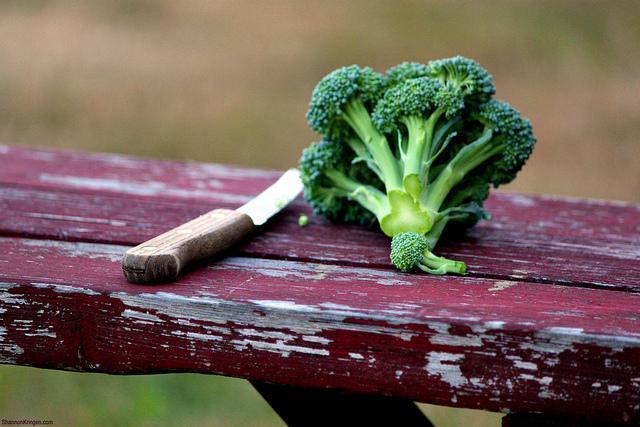How many people are to the immediate left of the motorcycle?
Give a very brief answer. 0. 